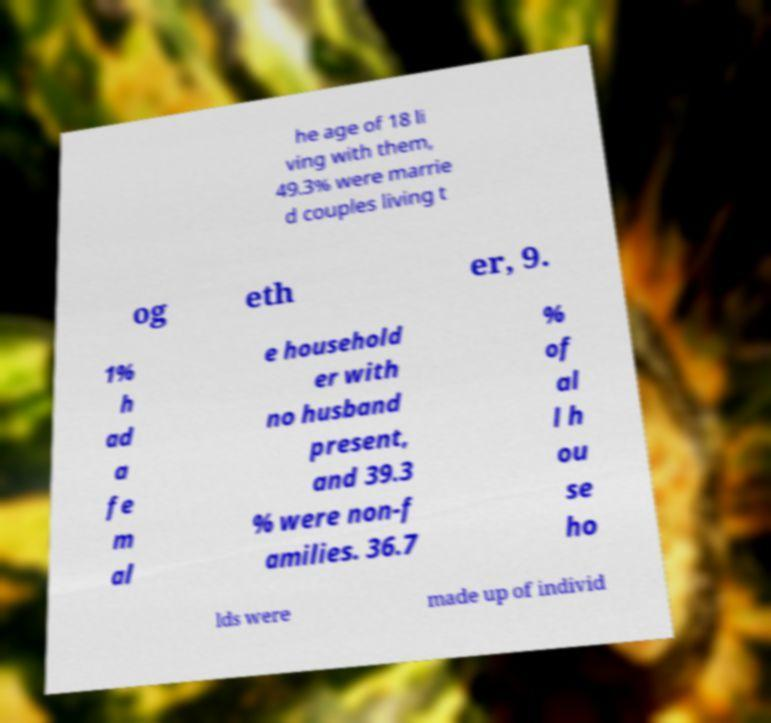Could you assist in decoding the text presented in this image and type it out clearly? he age of 18 li ving with them, 49.3% were marrie d couples living t og eth er, 9. 1% h ad a fe m al e household er with no husband present, and 39.3 % were non-f amilies. 36.7 % of al l h ou se ho lds were made up of individ 